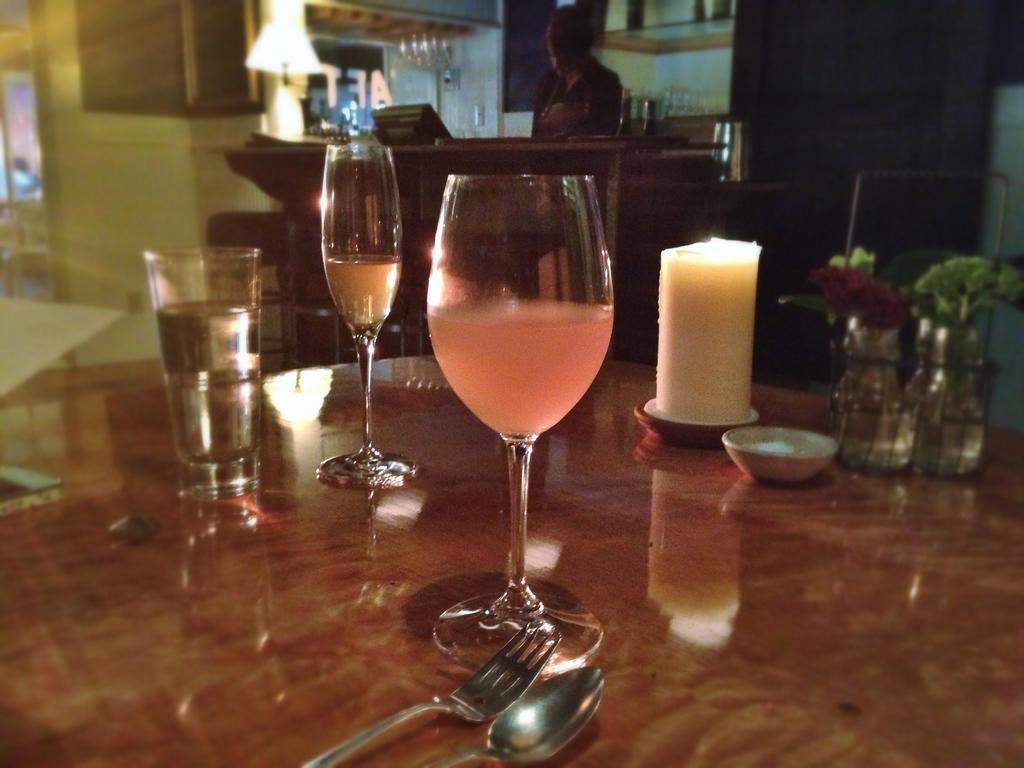In one or two sentences, can you explain what this image depicts? We can see glasses with liquids, spoon, fork, bowl, flower and objects on the table. In the background it is blue and there is a person and we can see monitor and glass on the table. 